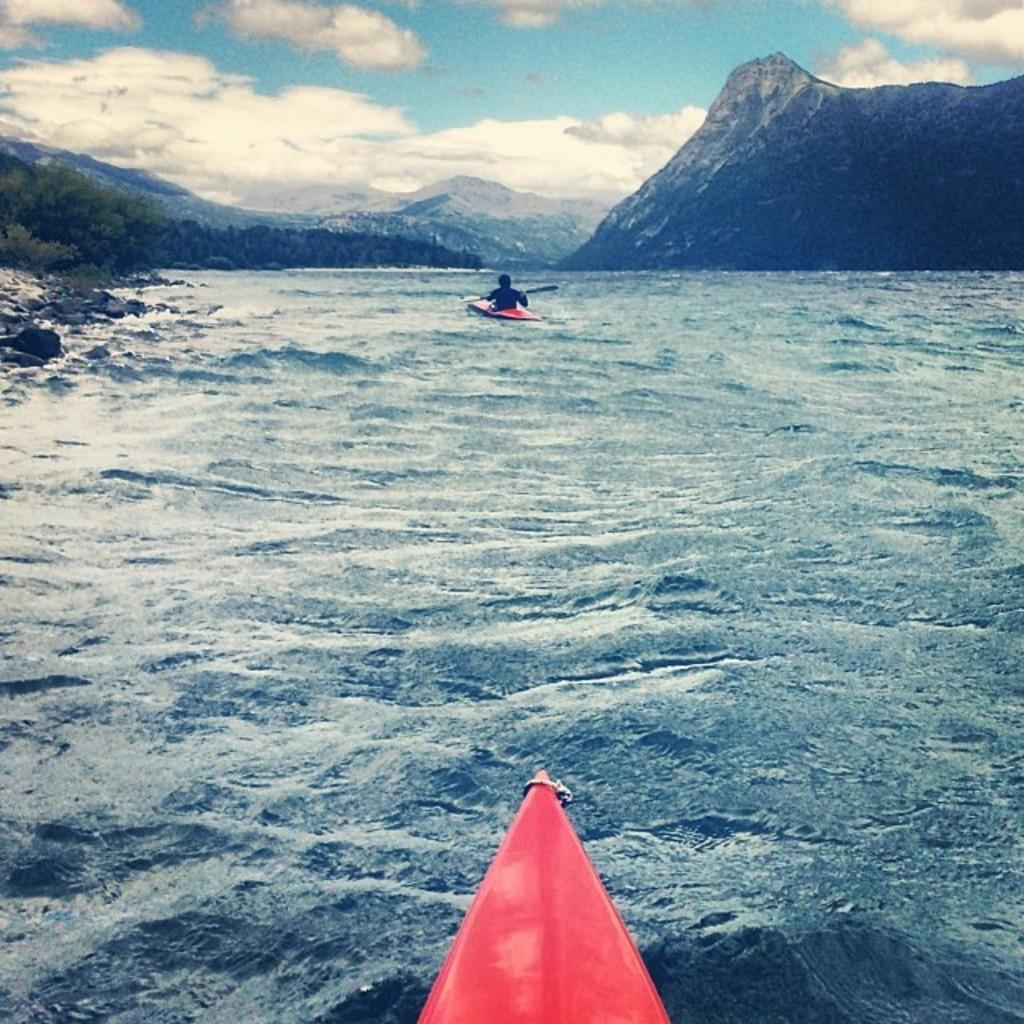What is the main subject of the image? There is a man in a boat in the image. Where is the boat located in the image? The boat is at the top side of the image. What can be seen on the left side of the image? There are trees on the left side of the image. What is in the center of the image? There is water in the center of the image. What color is the man's memory in the image? There is no mention of memory in the image, and therefore no color can be assigned to it. 